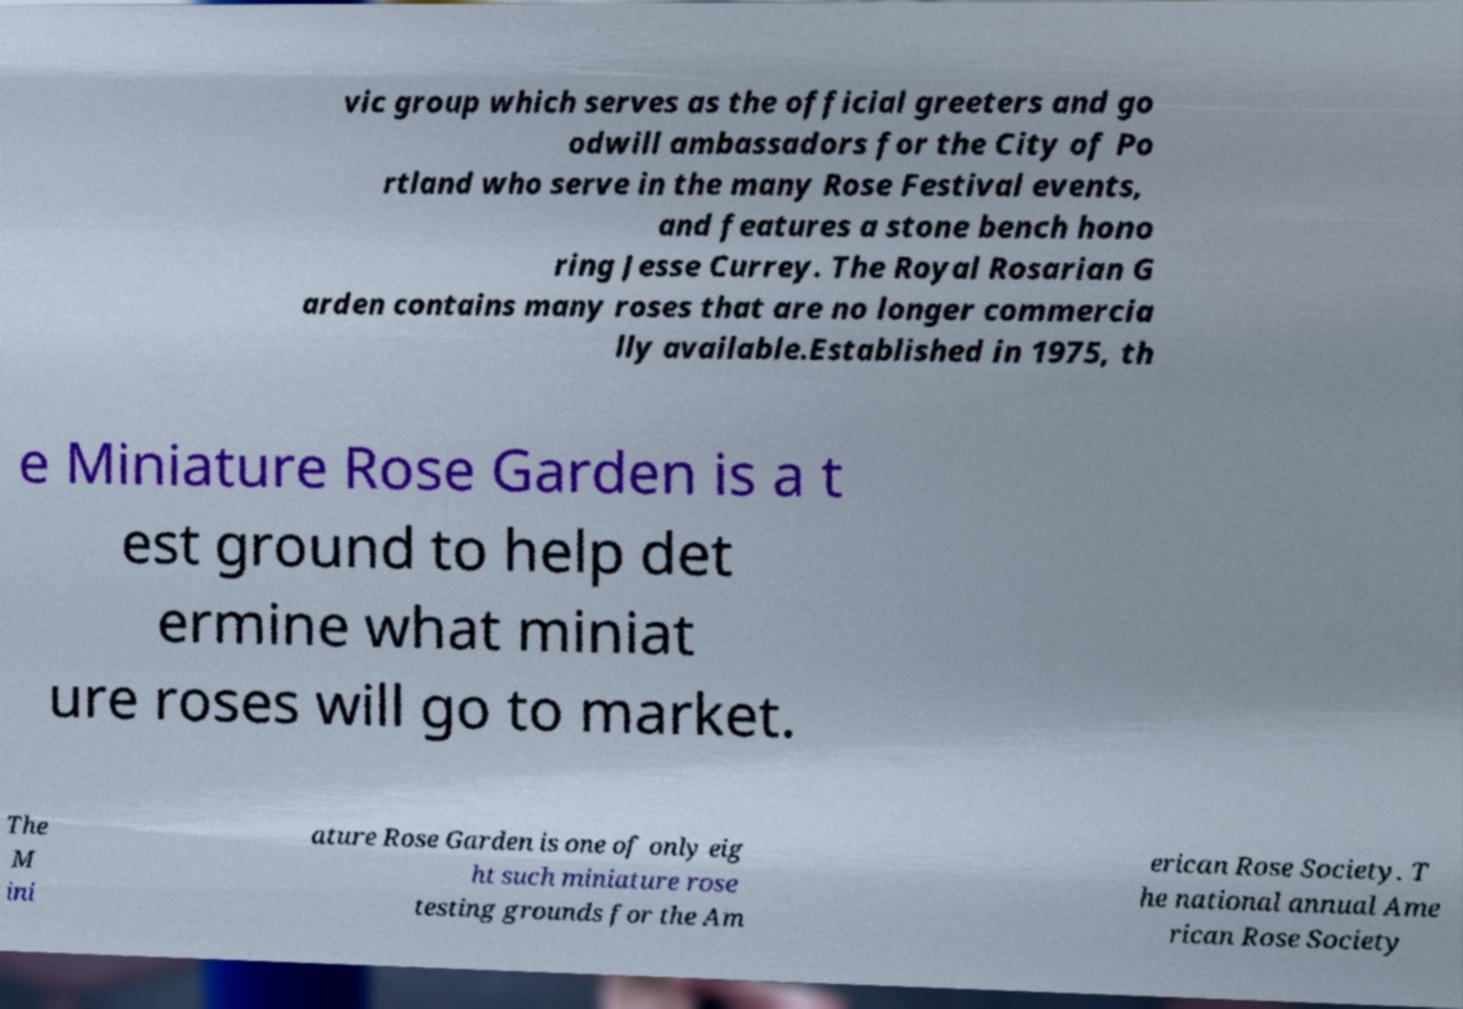Could you assist in decoding the text presented in this image and type it out clearly? vic group which serves as the official greeters and go odwill ambassadors for the City of Po rtland who serve in the many Rose Festival events, and features a stone bench hono ring Jesse Currey. The Royal Rosarian G arden contains many roses that are no longer commercia lly available.Established in 1975, th e Miniature Rose Garden is a t est ground to help det ermine what miniat ure roses will go to market. The M ini ature Rose Garden is one of only eig ht such miniature rose testing grounds for the Am erican Rose Society. T he national annual Ame rican Rose Society 